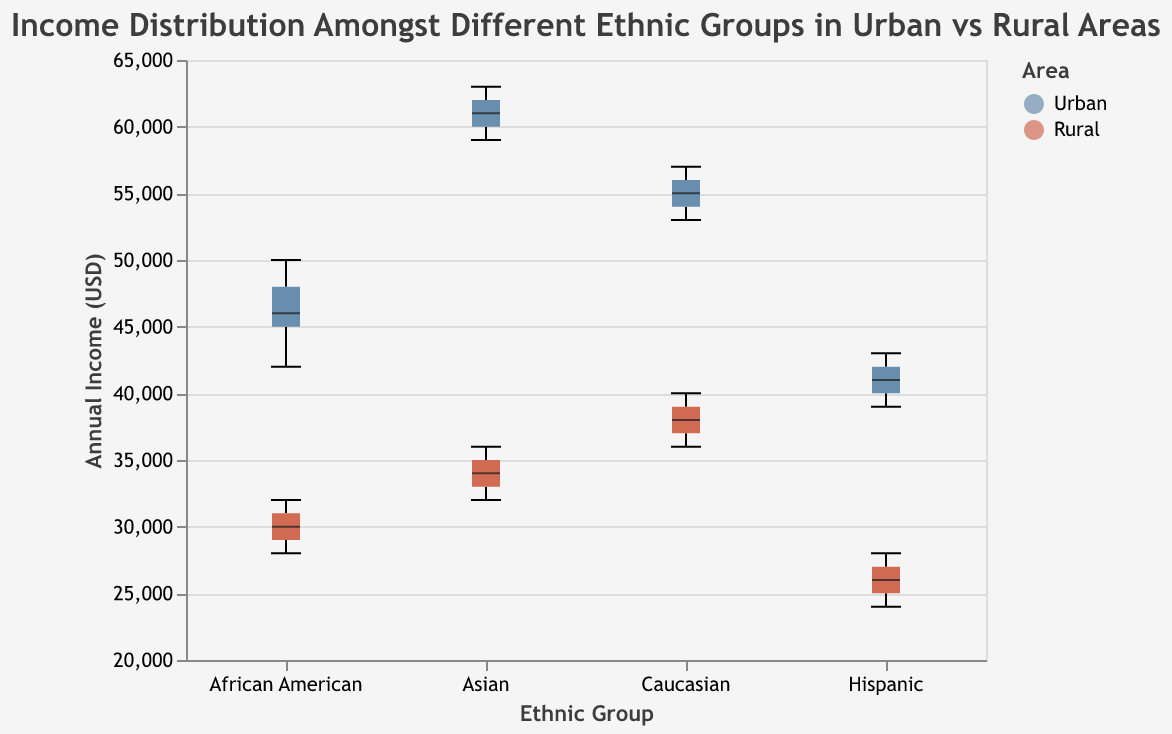what is the title of the figure? The title is displayed at the top of the figure, usually in a larger font. It provides a summary of what the figure is about.
Answer: Income Distribution Amongst Different Ethnic Groups in Urban vs Rural Areas How many ethnic groups are compared in the figure? The x-axis shows the ethnic groups' names exactly as they are represented in the data. Each unique label represents one ethnic group.
Answer: 4 Which area has higher income for the African American group, Urban or Rural? Look at the boxplot for African American and compare the boxes for the Urban and Rural areas. The Urban boxplot has a higher median and overall higher range of incomes.
Answer: Urban What is the median income for Hispanic in Urban areas? Find the boxplot corresponding to Hispanics in Urban areas and locate the bold line inside the box, which represents the median.
Answer: $41000 Which ethnic group in Urban areas has the highest income distribution? Compare the Urban boxplots across all ethnic groups by looking at the highest values in the boxplots. The highest income distribution will be evident by the topmost points in the boxes and whiskers.
Answer: Asian How does the income distribution for Caucasians in Rural areas compare to Asians in Rural areas? Visually compare the boxplots for Caucasians and Asians in the Rural area. Look at both the median lines and the overall spread (range) of the data.
Answer: The income distribution for Caucasians is higher overall than for Asians, both in terms of median and range What is the approximate range of incomes for African Americans in Rural areas? Identify the boxplot for African American in Rural areas and determine the lowest and highest points of the whiskers, which indicate the minimum and maximum incomes.
Answer: $28000 to $32000 Which ethnic group shows the smallest income range in Urban areas? Examine the Urban boxplots and compare the lengths of the boxes and whiskers, indicating the range of incomes for each ethnic group. The shortest boxplot represents the smallest range.
Answer: Hispanic For which area (Urban/Rural) and ethnic group is the difference between the maximum and minimum incomes the largest? Evaluate boxplots by looking at the full spread of whiskers (maximum to minimum incomes) for both Urban and Rural areas across all ethnic groups. The largest spread will represent the biggest difference.
Answer: Asian (Urban) Is the median income for Asians in Rural areas higher than the upper quartile for Hispanics in Rural areas? Find the median line for Asians in Rural and the upper edge of the boxplot for Hispanics in Rural. Compare the two values.
Answer: Yes 